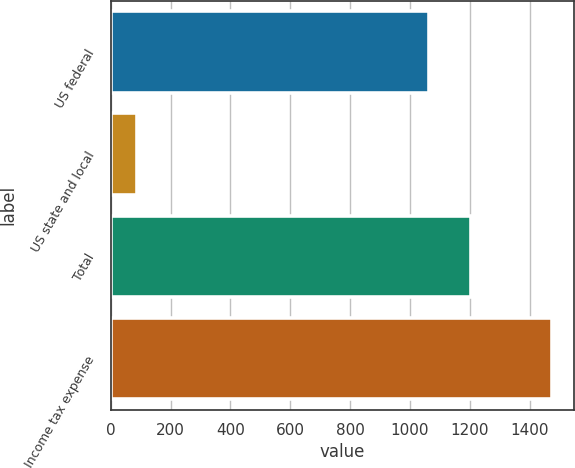Convert chart. <chart><loc_0><loc_0><loc_500><loc_500><bar_chart><fcel>US federal<fcel>US state and local<fcel>Total<fcel>Income tax expense<nl><fcel>1065<fcel>87<fcel>1203.7<fcel>1474<nl></chart> 